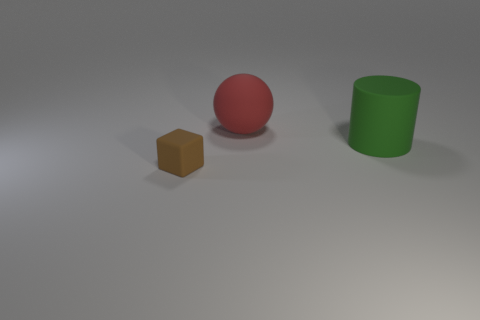Add 1 brown blocks. How many objects exist? 4 Subtract all balls. How many objects are left? 2 Subtract 1 spheres. How many spheres are left? 0 Add 2 small brown matte things. How many small brown matte things are left? 3 Add 1 red matte things. How many red matte things exist? 2 Subtract 0 red cylinders. How many objects are left? 3 Subtract all purple cubes. Subtract all yellow cylinders. How many cubes are left? 1 Subtract all cyan spheres. How many red cylinders are left? 0 Subtract all blue rubber things. Subtract all red matte spheres. How many objects are left? 2 